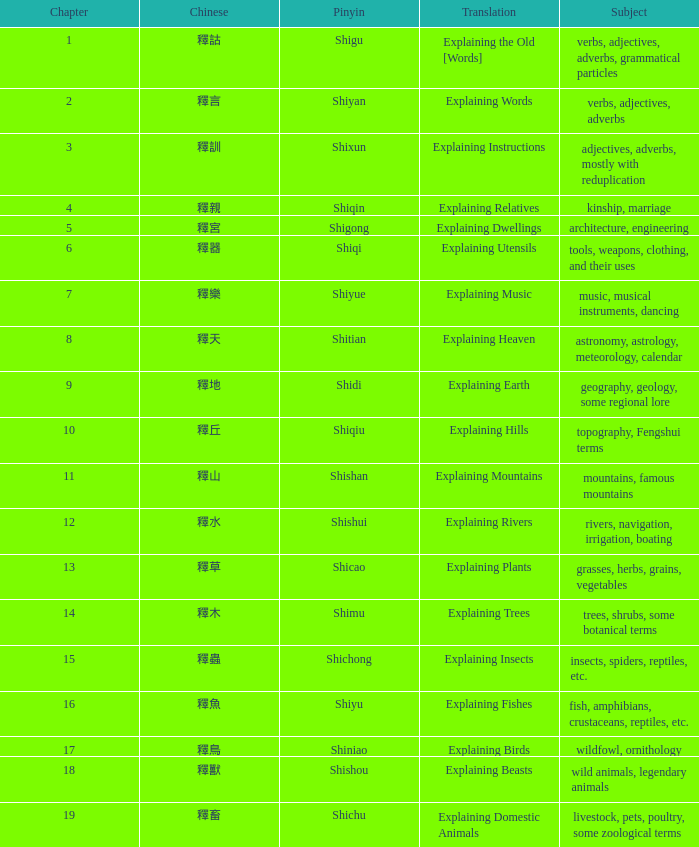Name the subject of shiyan Verbs, adjectives, adverbs. 